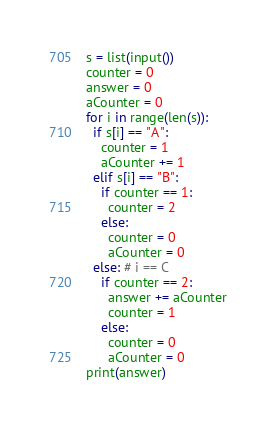Convert code to text. <code><loc_0><loc_0><loc_500><loc_500><_Python_>s = list(input())
counter = 0
answer = 0
aCounter = 0
for i in range(len(s)):
  if s[i] == "A":
    counter = 1
    aCounter += 1
  elif s[i] == "B":
    if counter == 1:
      counter = 2
    else:
      counter = 0
      aCounter = 0
  else: # i == C
    if counter == 2:
      answer += aCounter
      counter = 1
    else:
      counter = 0
      aCounter = 0
print(answer)</code> 